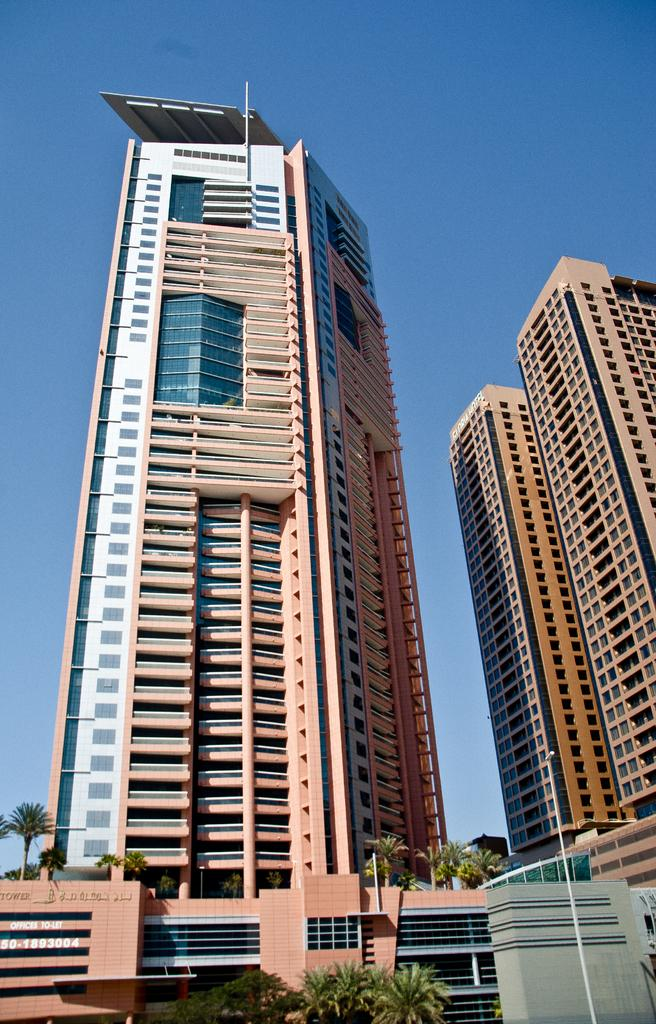What type of structures can be seen in the image? There are buildings in the image. What type of vegetation is present in the image? There are trees in the image. What other objects can be seen in the image? There are poles in the image. What is visible in the background of the image? The sky is visible in the image. How many copies of the straw are present in the image? There is no straw present in the image. What type of quiver can be seen in the image? There is no quiver present in the image. 